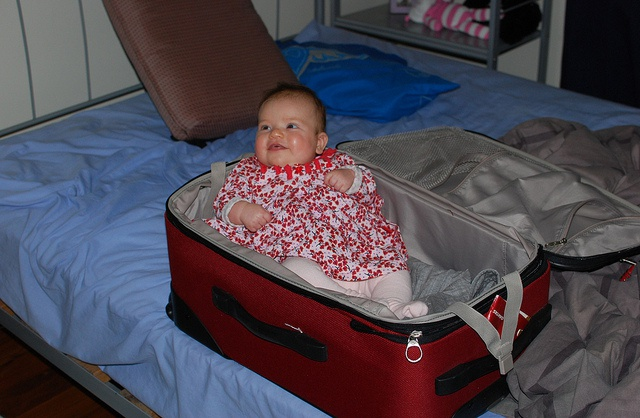Describe the objects in this image and their specific colors. I can see bed in gray, black, navy, and darkblue tones, suitcase in gray, black, and maroon tones, and people in gray, darkgray, brown, and maroon tones in this image. 